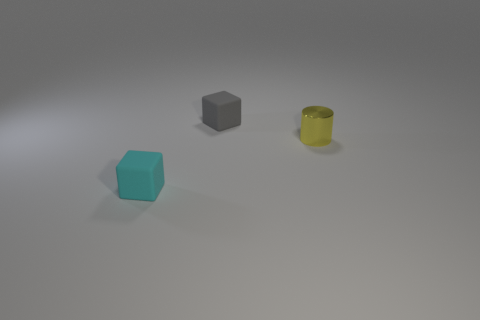Add 2 metal cylinders. How many objects exist? 5 Subtract all cubes. How many objects are left? 1 Subtract all tiny purple rubber spheres. Subtract all shiny cylinders. How many objects are left? 2 Add 1 small yellow shiny cylinders. How many small yellow shiny cylinders are left? 2 Add 2 tiny gray rubber objects. How many tiny gray rubber objects exist? 3 Subtract 0 brown cylinders. How many objects are left? 3 